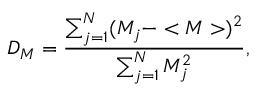<formula> <loc_0><loc_0><loc_500><loc_500>D _ { M } = \frac { \sum _ { j = 1 } ^ { N } ( M _ { j } - < M > ) ^ { 2 } } { \sum _ { j = 1 } ^ { N } M _ { j } ^ { 2 } } ,</formula> 